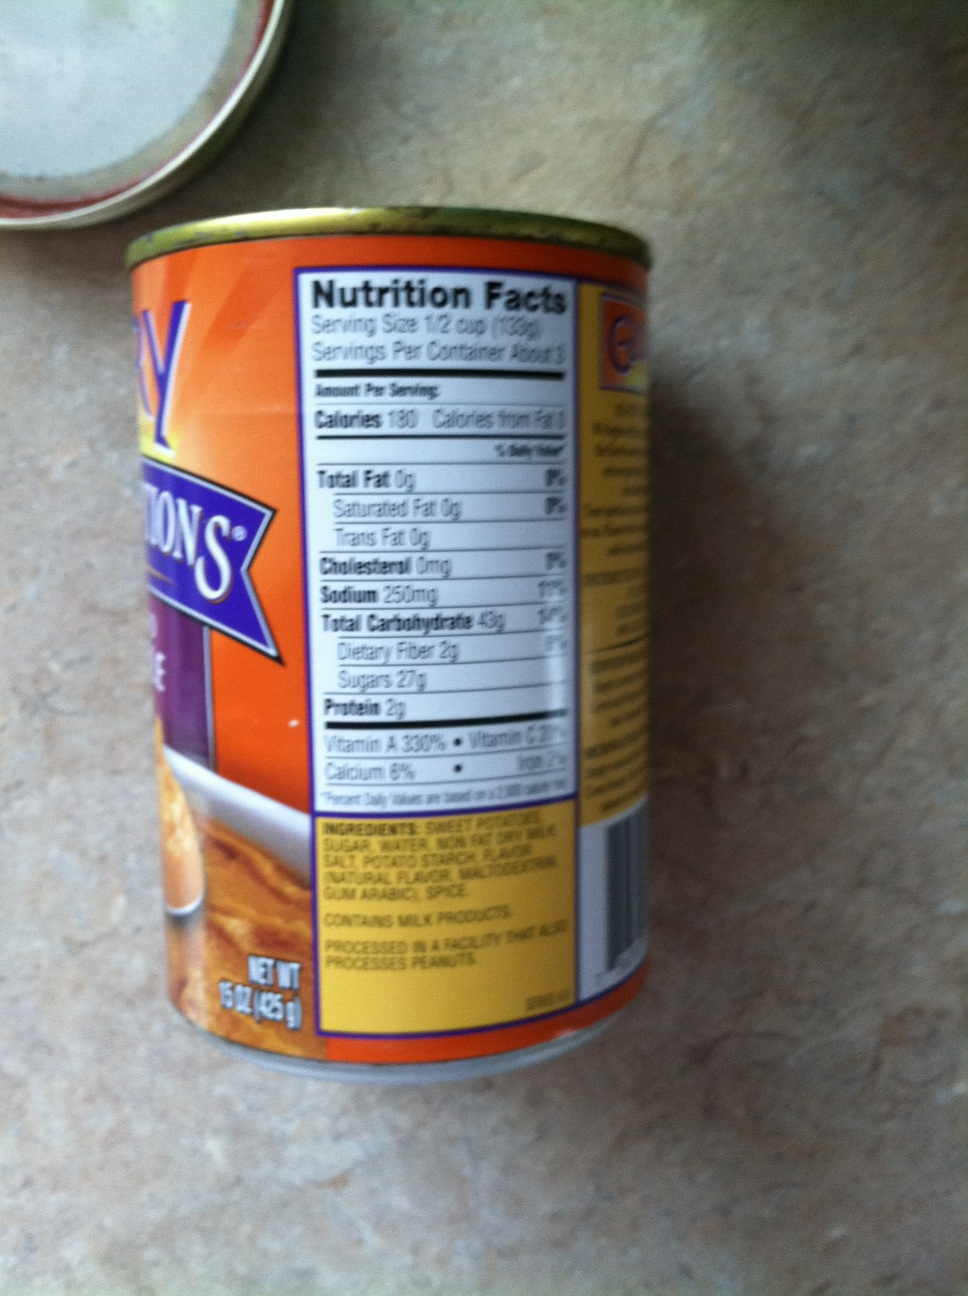What real-life scenario could you imagine for this product? In a real-life scenario, this tin of sweet potatoes could be used during a family Thanksgiving dinner. Sweet potatoes are a traditional ingredient in many holiday dishes, such as sweet potato casserole topped with marshmallows or a savory roasted sweet potato side dish. The convenience of the canned sweet potatoes would save preparation time, allowing the cook to focus on perfecting the meal's other elements and enjoying time with family and friends. 